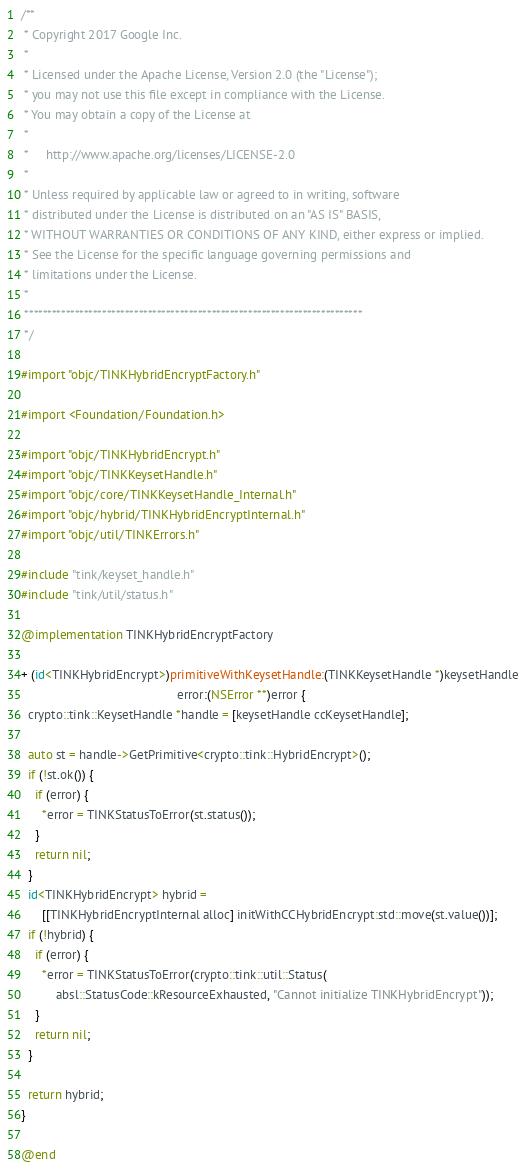Convert code to text. <code><loc_0><loc_0><loc_500><loc_500><_ObjectiveC_>/**
 * Copyright 2017 Google Inc.
 *
 * Licensed under the Apache License, Version 2.0 (the "License");
 * you may not use this file except in compliance with the License.
 * You may obtain a copy of the License at
 *
 *     http://www.apache.org/licenses/LICENSE-2.0
 *
 * Unless required by applicable law or agreed to in writing, software
 * distributed under the License is distributed on an "AS IS" BASIS,
 * WITHOUT WARRANTIES OR CONDITIONS OF ANY KIND, either express or implied.
 * See the License for the specific language governing permissions and
 * limitations under the License.
 *
 **************************************************************************
 */

#import "objc/TINKHybridEncryptFactory.h"

#import <Foundation/Foundation.h>

#import "objc/TINKHybridEncrypt.h"
#import "objc/TINKKeysetHandle.h"
#import "objc/core/TINKKeysetHandle_Internal.h"
#import "objc/hybrid/TINKHybridEncryptInternal.h"
#import "objc/util/TINKErrors.h"

#include "tink/keyset_handle.h"
#include "tink/util/status.h"

@implementation TINKHybridEncryptFactory

+ (id<TINKHybridEncrypt>)primitiveWithKeysetHandle:(TINKKeysetHandle *)keysetHandle
                                             error:(NSError **)error {
  crypto::tink::KeysetHandle *handle = [keysetHandle ccKeysetHandle];

  auto st = handle->GetPrimitive<crypto::tink::HybridEncrypt>();
  if (!st.ok()) {
    if (error) {
      *error = TINKStatusToError(st.status());
    }
    return nil;
  }
  id<TINKHybridEncrypt> hybrid =
      [[TINKHybridEncryptInternal alloc] initWithCCHybridEncrypt:std::move(st.value())];
  if (!hybrid) {
    if (error) {
      *error = TINKStatusToError(crypto::tink::util::Status(
          absl::StatusCode::kResourceExhausted, "Cannot initialize TINKHybridEncrypt"));
    }
    return nil;
  }

  return hybrid;
}

@end
</code> 